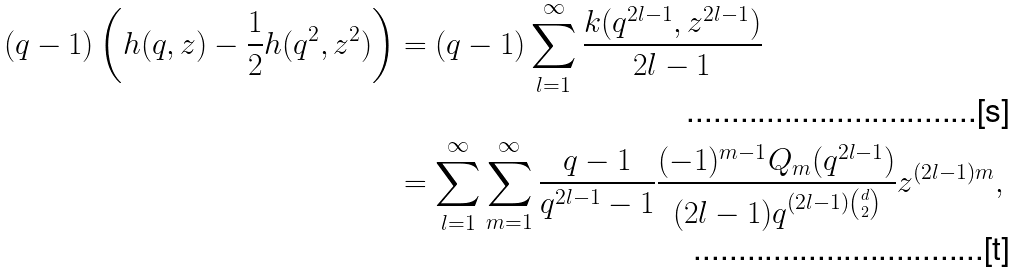Convert formula to latex. <formula><loc_0><loc_0><loc_500><loc_500>( q - 1 ) \left ( h ( q , z ) - \frac { 1 } { 2 } h ( q ^ { 2 } , z ^ { 2 } ) \right ) & = ( q - 1 ) \sum _ { l = 1 } ^ { \infty } \frac { k ( q ^ { 2 l - 1 } , z ^ { 2 l - 1 } ) } { 2 l - 1 } \\ & = \sum _ { l = 1 } ^ { \infty } \sum _ { m = 1 } ^ { \infty } \frac { q - 1 } { q ^ { 2 l - 1 } - 1 } \frac { ( - 1 ) ^ { m - 1 } Q _ { m } ( q ^ { 2 l - 1 } ) } { ( 2 l - 1 ) q ^ { ( 2 l - 1 ) \binom { d } { 2 } } } z ^ { ( 2 l - 1 ) m } ,</formula> 